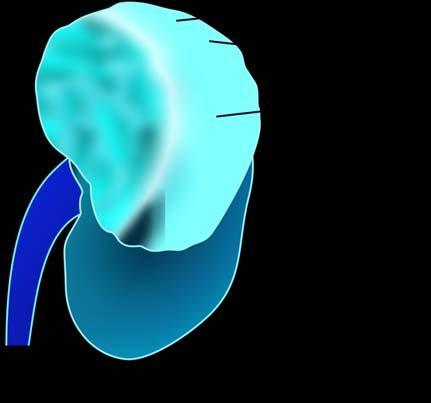what shows a large and tan mass while rest of the kidney has reniform contour?
Answer the question using a single word or phrase. Upper pole of the kidney 